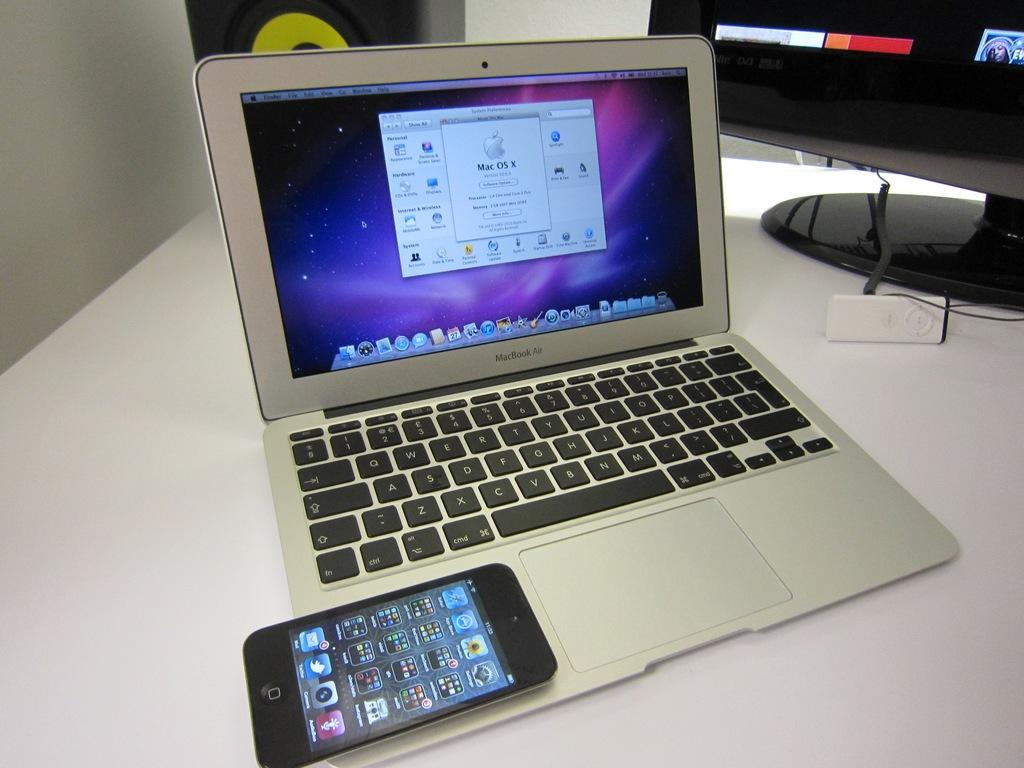Provide a one-sentence caption for the provided image. A MacBook Air sits open on a table with an iPhone resting next to the trackpad. 